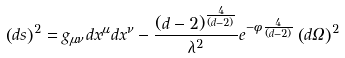Convert formula to latex. <formula><loc_0><loc_0><loc_500><loc_500>\left ( d s \right ) ^ { 2 } = g _ { \mu \nu } d x ^ { \mu } d x ^ { \nu } - \frac { ( d - 2 ) ^ { \frac { 4 } { ( d - 2 ) } } } { \lambda ^ { 2 } } e ^ { - \phi \frac { 4 } { ( d - 2 ) } } \left ( d \Omega \right ) ^ { 2 }</formula> 